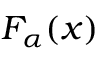Convert formula to latex. <formula><loc_0><loc_0><loc_500><loc_500>F _ { \alpha } ( x )</formula> 